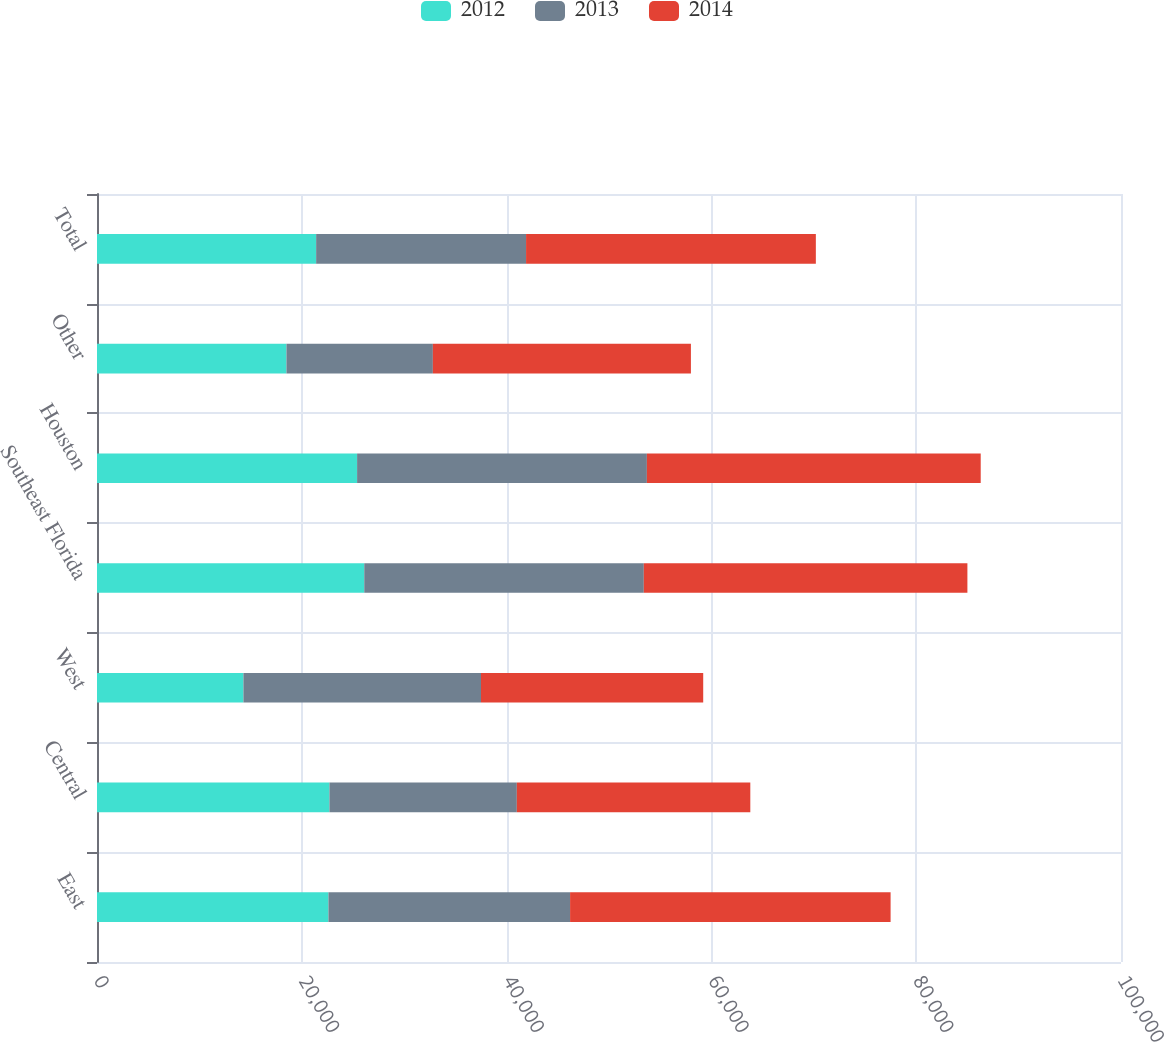Convert chart. <chart><loc_0><loc_0><loc_500><loc_500><stacked_bar_chart><ecel><fcel>East<fcel>Central<fcel>West<fcel>Southeast Florida<fcel>Houston<fcel>Other<fcel>Total<nl><fcel>2012<fcel>22600<fcel>22700<fcel>14300<fcel>26100<fcel>25400<fcel>18500<fcel>21400<nl><fcel>2013<fcel>23600<fcel>18300<fcel>23200<fcel>27300<fcel>28300<fcel>14300<fcel>20500<nl><fcel>2014<fcel>31300<fcel>22800<fcel>21700<fcel>31600<fcel>32600<fcel>25200<fcel>28300<nl></chart> 